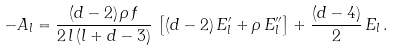<formula> <loc_0><loc_0><loc_500><loc_500>- A _ { l } = \frac { ( d - 2 ) \, \rho \, f } { 2 \, l \, ( l + d - 3 ) } \, \left [ ( d - 2 ) \, E _ { l } ^ { \prime } + \rho \, E _ { l } ^ { \prime \prime } \right ] + \frac { ( d - 4 ) } { 2 } \, E _ { l } \, .</formula> 